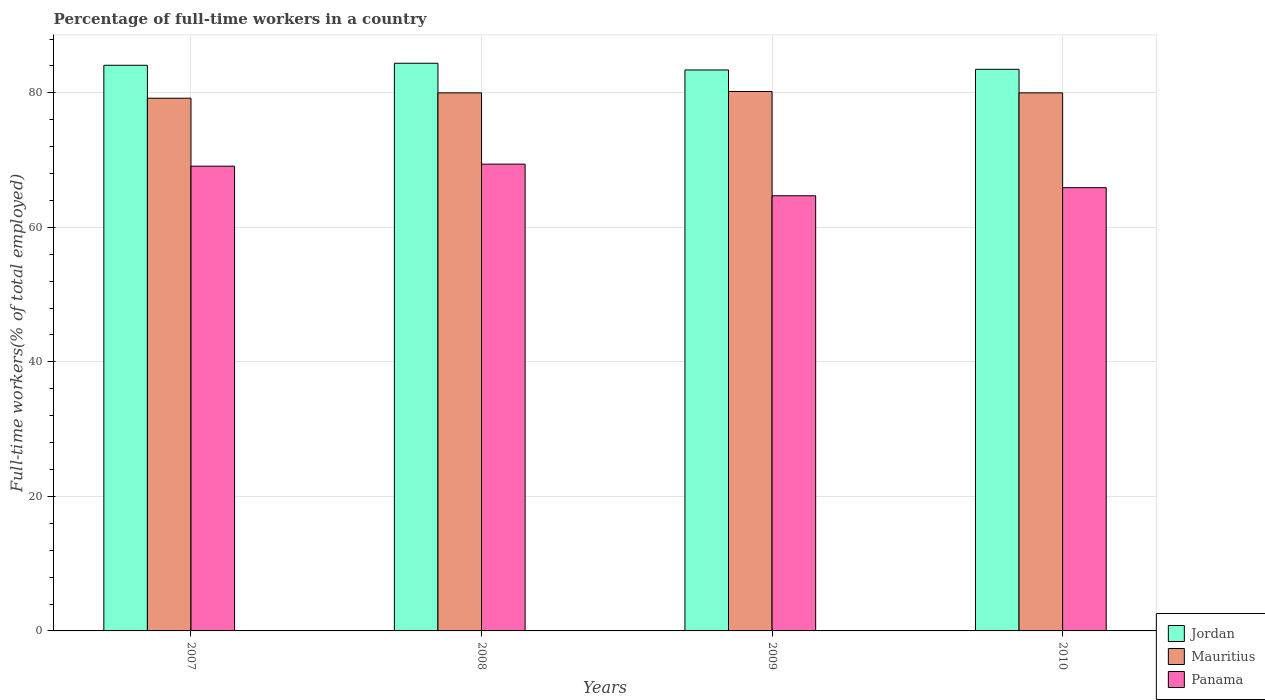How many groups of bars are there?
Keep it short and to the point. 4. Are the number of bars per tick equal to the number of legend labels?
Ensure brevity in your answer.  Yes. How many bars are there on the 1st tick from the left?
Keep it short and to the point. 3. What is the percentage of full-time workers in Panama in 2007?
Ensure brevity in your answer.  69.1. Across all years, what is the maximum percentage of full-time workers in Panama?
Provide a succinct answer. 69.4. Across all years, what is the minimum percentage of full-time workers in Mauritius?
Your response must be concise. 79.2. In which year was the percentage of full-time workers in Mauritius minimum?
Your answer should be very brief. 2007. What is the total percentage of full-time workers in Jordan in the graph?
Your answer should be very brief. 335.4. What is the difference between the percentage of full-time workers in Jordan in 2007 and the percentage of full-time workers in Panama in 2008?
Your response must be concise. 14.7. What is the average percentage of full-time workers in Panama per year?
Offer a terse response. 67.27. In the year 2008, what is the difference between the percentage of full-time workers in Panama and percentage of full-time workers in Jordan?
Keep it short and to the point. -15. What is the ratio of the percentage of full-time workers in Jordan in 2007 to that in 2008?
Provide a short and direct response. 1. Is the percentage of full-time workers in Mauritius in 2008 less than that in 2009?
Give a very brief answer. Yes. What is the difference between the highest and the second highest percentage of full-time workers in Mauritius?
Give a very brief answer. 0.2. What is the difference between the highest and the lowest percentage of full-time workers in Panama?
Offer a terse response. 4.7. Is the sum of the percentage of full-time workers in Panama in 2009 and 2010 greater than the maximum percentage of full-time workers in Mauritius across all years?
Offer a terse response. Yes. What does the 2nd bar from the left in 2009 represents?
Your answer should be very brief. Mauritius. What does the 2nd bar from the right in 2007 represents?
Make the answer very short. Mauritius. Are all the bars in the graph horizontal?
Keep it short and to the point. No. What is the difference between two consecutive major ticks on the Y-axis?
Ensure brevity in your answer.  20. Are the values on the major ticks of Y-axis written in scientific E-notation?
Make the answer very short. No. Does the graph contain any zero values?
Your answer should be very brief. No. Where does the legend appear in the graph?
Provide a succinct answer. Bottom right. What is the title of the graph?
Your answer should be compact. Percentage of full-time workers in a country. What is the label or title of the Y-axis?
Your answer should be compact. Full-time workers(% of total employed). What is the Full-time workers(% of total employed) of Jordan in 2007?
Ensure brevity in your answer.  84.1. What is the Full-time workers(% of total employed) of Mauritius in 2007?
Give a very brief answer. 79.2. What is the Full-time workers(% of total employed) of Panama in 2007?
Provide a succinct answer. 69.1. What is the Full-time workers(% of total employed) in Jordan in 2008?
Your response must be concise. 84.4. What is the Full-time workers(% of total employed) of Panama in 2008?
Offer a very short reply. 69.4. What is the Full-time workers(% of total employed) of Jordan in 2009?
Keep it short and to the point. 83.4. What is the Full-time workers(% of total employed) of Mauritius in 2009?
Your answer should be very brief. 80.2. What is the Full-time workers(% of total employed) in Panama in 2009?
Keep it short and to the point. 64.7. What is the Full-time workers(% of total employed) of Jordan in 2010?
Your answer should be compact. 83.5. What is the Full-time workers(% of total employed) in Mauritius in 2010?
Your answer should be very brief. 80. What is the Full-time workers(% of total employed) in Panama in 2010?
Make the answer very short. 65.9. Across all years, what is the maximum Full-time workers(% of total employed) in Jordan?
Your response must be concise. 84.4. Across all years, what is the maximum Full-time workers(% of total employed) of Mauritius?
Your answer should be compact. 80.2. Across all years, what is the maximum Full-time workers(% of total employed) of Panama?
Your answer should be very brief. 69.4. Across all years, what is the minimum Full-time workers(% of total employed) of Jordan?
Your answer should be compact. 83.4. Across all years, what is the minimum Full-time workers(% of total employed) of Mauritius?
Your answer should be compact. 79.2. Across all years, what is the minimum Full-time workers(% of total employed) in Panama?
Give a very brief answer. 64.7. What is the total Full-time workers(% of total employed) of Jordan in the graph?
Keep it short and to the point. 335.4. What is the total Full-time workers(% of total employed) of Mauritius in the graph?
Your answer should be compact. 319.4. What is the total Full-time workers(% of total employed) of Panama in the graph?
Your answer should be very brief. 269.1. What is the difference between the Full-time workers(% of total employed) in Jordan in 2007 and that in 2008?
Your answer should be compact. -0.3. What is the difference between the Full-time workers(% of total employed) of Jordan in 2007 and that in 2009?
Provide a short and direct response. 0.7. What is the difference between the Full-time workers(% of total employed) in Mauritius in 2007 and that in 2009?
Ensure brevity in your answer.  -1. What is the difference between the Full-time workers(% of total employed) of Jordan in 2007 and that in 2010?
Your answer should be compact. 0.6. What is the difference between the Full-time workers(% of total employed) of Mauritius in 2007 and that in 2010?
Provide a succinct answer. -0.8. What is the difference between the Full-time workers(% of total employed) in Jordan in 2008 and that in 2009?
Ensure brevity in your answer.  1. What is the difference between the Full-time workers(% of total employed) in Mauritius in 2008 and that in 2009?
Make the answer very short. -0.2. What is the difference between the Full-time workers(% of total employed) of Jordan in 2008 and that in 2010?
Your answer should be very brief. 0.9. What is the difference between the Full-time workers(% of total employed) in Mauritius in 2008 and that in 2010?
Ensure brevity in your answer.  0. What is the difference between the Full-time workers(% of total employed) in Panama in 2008 and that in 2010?
Make the answer very short. 3.5. What is the difference between the Full-time workers(% of total employed) of Panama in 2009 and that in 2010?
Offer a very short reply. -1.2. What is the difference between the Full-time workers(% of total employed) of Jordan in 2007 and the Full-time workers(% of total employed) of Panama in 2008?
Your answer should be very brief. 14.7. What is the difference between the Full-time workers(% of total employed) of Jordan in 2007 and the Full-time workers(% of total employed) of Panama in 2009?
Your response must be concise. 19.4. What is the difference between the Full-time workers(% of total employed) in Mauritius in 2007 and the Full-time workers(% of total employed) in Panama in 2009?
Provide a succinct answer. 14.5. What is the difference between the Full-time workers(% of total employed) in Jordan in 2007 and the Full-time workers(% of total employed) in Mauritius in 2010?
Offer a terse response. 4.1. What is the difference between the Full-time workers(% of total employed) of Mauritius in 2007 and the Full-time workers(% of total employed) of Panama in 2010?
Provide a short and direct response. 13.3. What is the difference between the Full-time workers(% of total employed) of Jordan in 2008 and the Full-time workers(% of total employed) of Panama in 2009?
Your response must be concise. 19.7. What is the average Full-time workers(% of total employed) of Jordan per year?
Your response must be concise. 83.85. What is the average Full-time workers(% of total employed) in Mauritius per year?
Your answer should be compact. 79.85. What is the average Full-time workers(% of total employed) of Panama per year?
Make the answer very short. 67.28. In the year 2009, what is the difference between the Full-time workers(% of total employed) of Jordan and Full-time workers(% of total employed) of Mauritius?
Offer a very short reply. 3.2. In the year 2009, what is the difference between the Full-time workers(% of total employed) of Mauritius and Full-time workers(% of total employed) of Panama?
Your answer should be very brief. 15.5. In the year 2010, what is the difference between the Full-time workers(% of total employed) in Jordan and Full-time workers(% of total employed) in Mauritius?
Your answer should be compact. 3.5. In the year 2010, what is the difference between the Full-time workers(% of total employed) in Jordan and Full-time workers(% of total employed) in Panama?
Your answer should be compact. 17.6. What is the ratio of the Full-time workers(% of total employed) in Jordan in 2007 to that in 2009?
Keep it short and to the point. 1.01. What is the ratio of the Full-time workers(% of total employed) of Mauritius in 2007 to that in 2009?
Offer a very short reply. 0.99. What is the ratio of the Full-time workers(% of total employed) in Panama in 2007 to that in 2009?
Make the answer very short. 1.07. What is the ratio of the Full-time workers(% of total employed) of Jordan in 2007 to that in 2010?
Make the answer very short. 1.01. What is the ratio of the Full-time workers(% of total employed) in Panama in 2007 to that in 2010?
Provide a succinct answer. 1.05. What is the ratio of the Full-time workers(% of total employed) of Jordan in 2008 to that in 2009?
Your response must be concise. 1.01. What is the ratio of the Full-time workers(% of total employed) of Panama in 2008 to that in 2009?
Ensure brevity in your answer.  1.07. What is the ratio of the Full-time workers(% of total employed) in Jordan in 2008 to that in 2010?
Your answer should be compact. 1.01. What is the ratio of the Full-time workers(% of total employed) in Panama in 2008 to that in 2010?
Provide a succinct answer. 1.05. What is the ratio of the Full-time workers(% of total employed) in Mauritius in 2009 to that in 2010?
Make the answer very short. 1. What is the ratio of the Full-time workers(% of total employed) of Panama in 2009 to that in 2010?
Your answer should be very brief. 0.98. What is the difference between the highest and the second highest Full-time workers(% of total employed) in Mauritius?
Make the answer very short. 0.2. What is the difference between the highest and the second highest Full-time workers(% of total employed) of Panama?
Provide a short and direct response. 0.3. What is the difference between the highest and the lowest Full-time workers(% of total employed) in Jordan?
Offer a terse response. 1. What is the difference between the highest and the lowest Full-time workers(% of total employed) in Mauritius?
Make the answer very short. 1. What is the difference between the highest and the lowest Full-time workers(% of total employed) in Panama?
Your answer should be compact. 4.7. 